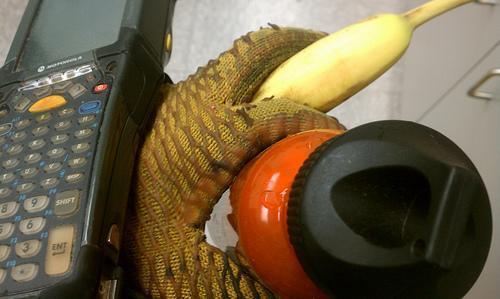How many bananas are shown?
Give a very brief answer. 1. How many cabinet handles are shown?
Give a very brief answer. 2. 